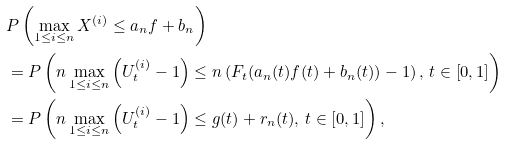Convert formula to latex. <formula><loc_0><loc_0><loc_500><loc_500>& P \left ( \max _ { 1 \leq i \leq n } X ^ { ( i ) } \leq a _ { n } f + b _ { n } \right ) \\ & = P \left ( n \max _ { 1 \leq i \leq n } \left ( U _ { t } ^ { ( i ) } - 1 \right ) \leq n \left ( F _ { t } ( a _ { n } ( t ) f ( t ) + b _ { n } ( t ) ) - 1 \right ) , \, t \in [ 0 , 1 ] \right ) \\ & = P \left ( n \max _ { 1 \leq i \leq n } \left ( U _ { t } ^ { ( i ) } - 1 \right ) \leq g ( t ) + r _ { n } ( t ) , \, t \in [ 0 , 1 ] \right ) ,</formula> 